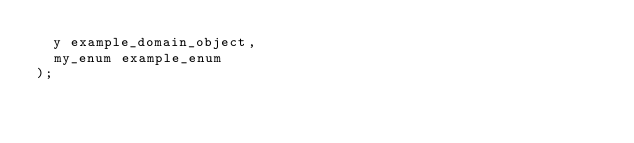<code> <loc_0><loc_0><loc_500><loc_500><_SQL_>  y example_domain_object,
  my_enum example_enum
);
</code> 